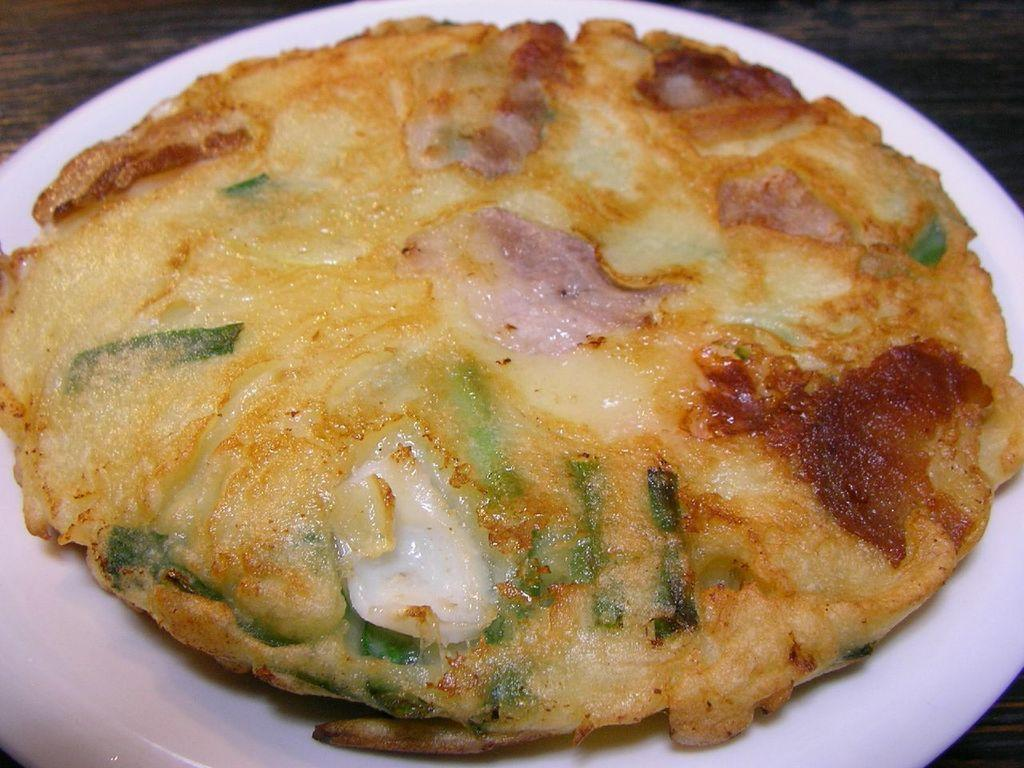What type of food is the main subject of the image? There is a pizza in the image. How is the pizza presented in the image? The pizza is on a plate. What type of pie can be seen in the image? There is no pie present in the image; it features a pizza. Can you tell me where the park is located in the image? There is no park present in the image; it only shows a pizza on a plate. 